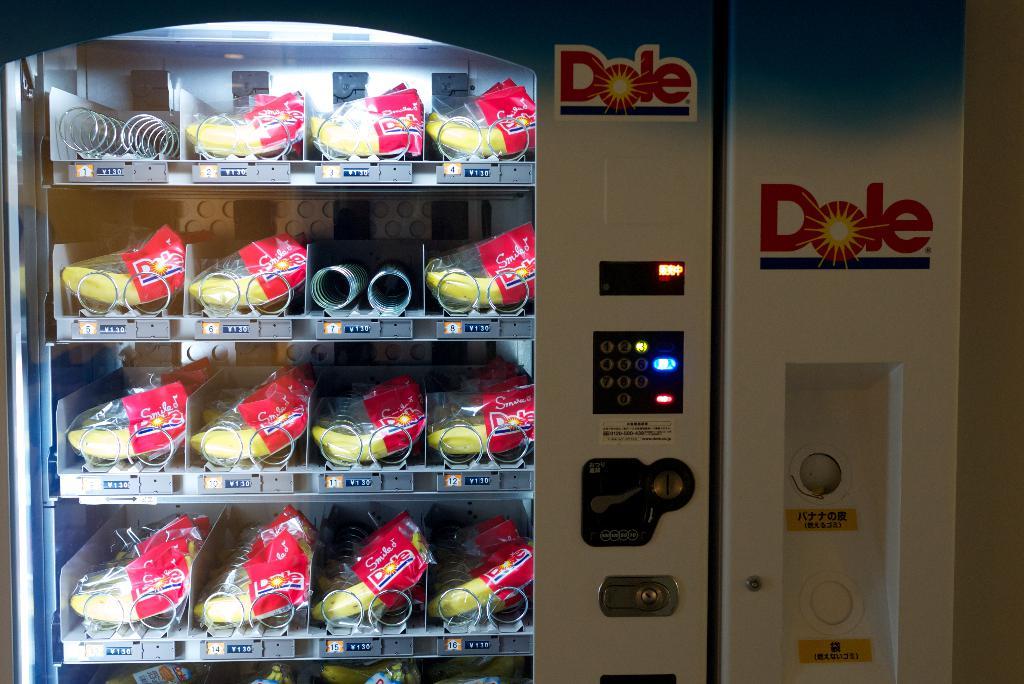What brand is this machine selling?
Keep it short and to the point. Dole. 